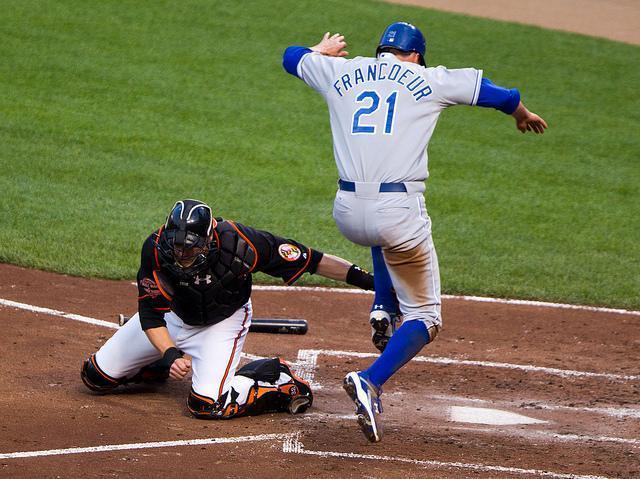How many people are there?
Give a very brief answer. 2. 